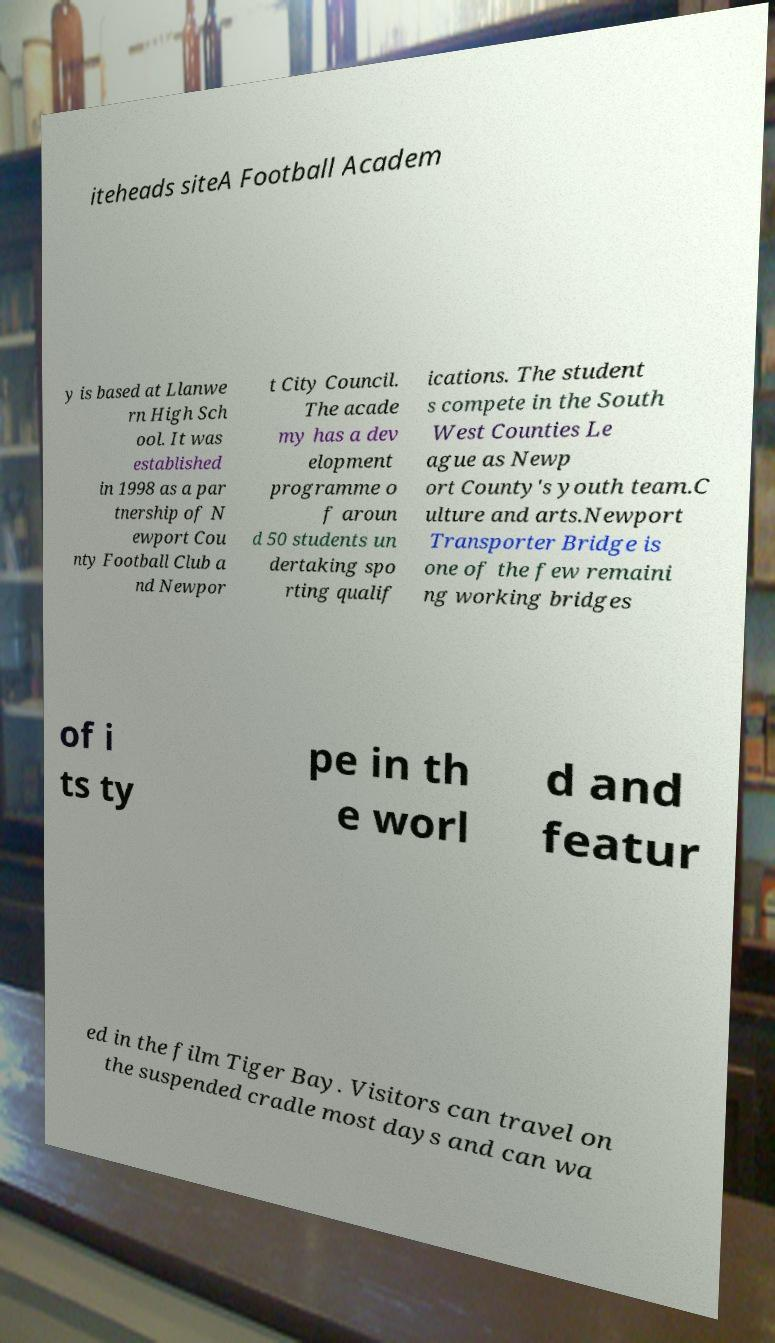Can you read and provide the text displayed in the image?This photo seems to have some interesting text. Can you extract and type it out for me? iteheads siteA Football Academ y is based at Llanwe rn High Sch ool. It was established in 1998 as a par tnership of N ewport Cou nty Football Club a nd Newpor t City Council. The acade my has a dev elopment programme o f aroun d 50 students un dertaking spo rting qualif ications. The student s compete in the South West Counties Le ague as Newp ort County's youth team.C ulture and arts.Newport Transporter Bridge is one of the few remaini ng working bridges of i ts ty pe in th e worl d and featur ed in the film Tiger Bay. Visitors can travel on the suspended cradle most days and can wa 